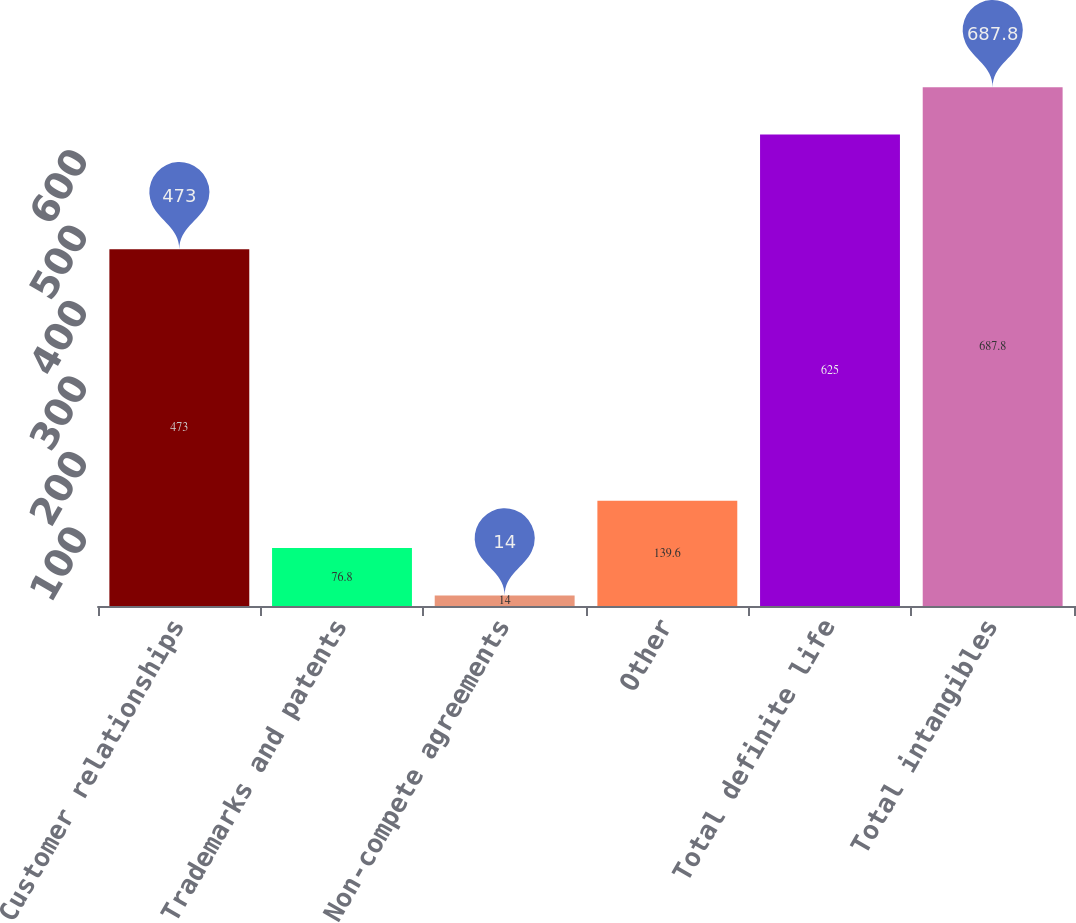<chart> <loc_0><loc_0><loc_500><loc_500><bar_chart><fcel>Customer relationships<fcel>Trademarks and patents<fcel>Non-compete agreements<fcel>Other<fcel>Total definite life<fcel>Total intangibles<nl><fcel>473<fcel>76.8<fcel>14<fcel>139.6<fcel>625<fcel>687.8<nl></chart> 